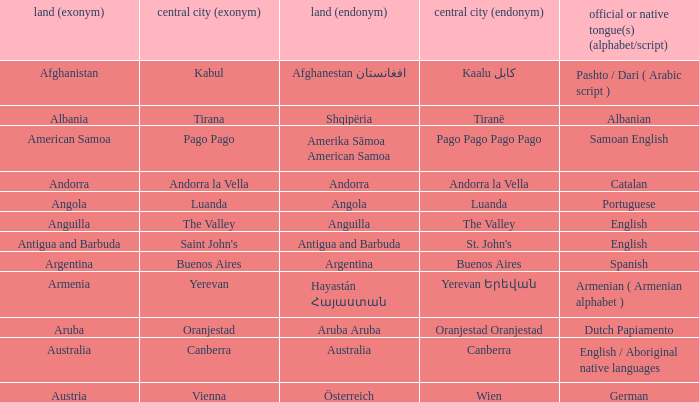How many capital cities does Australia have? 1.0. 